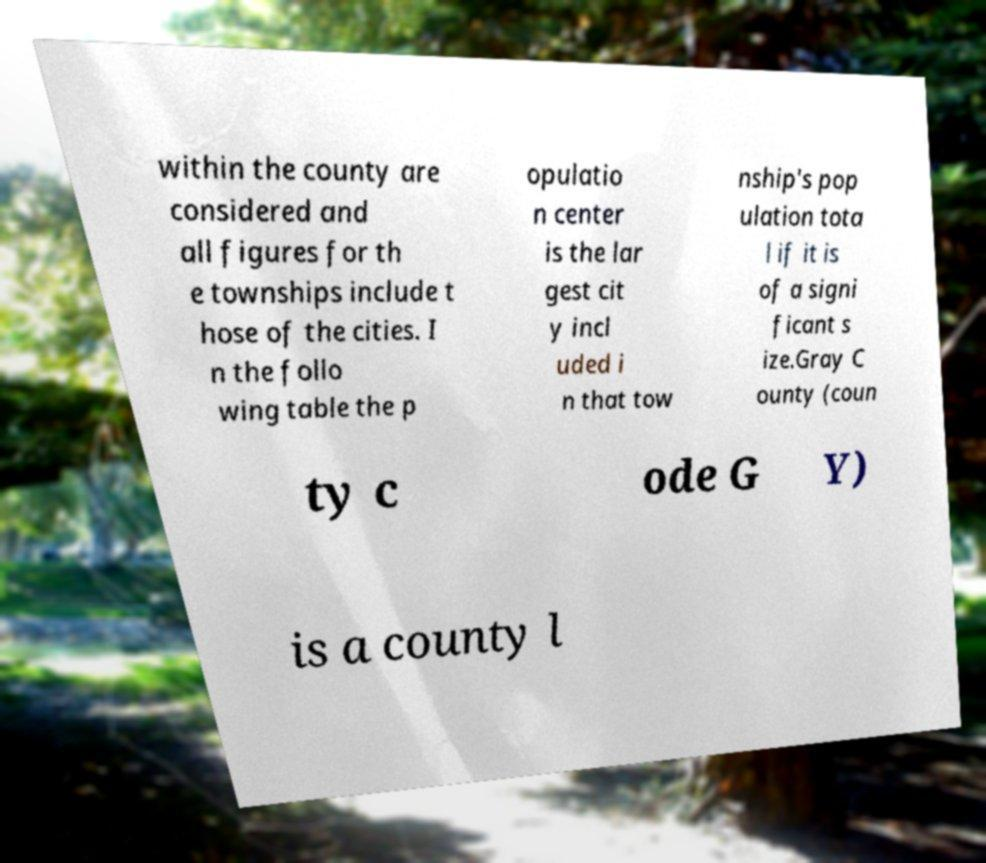Can you accurately transcribe the text from the provided image for me? within the county are considered and all figures for th e townships include t hose of the cities. I n the follo wing table the p opulatio n center is the lar gest cit y incl uded i n that tow nship's pop ulation tota l if it is of a signi ficant s ize.Gray C ounty (coun ty c ode G Y) is a county l 